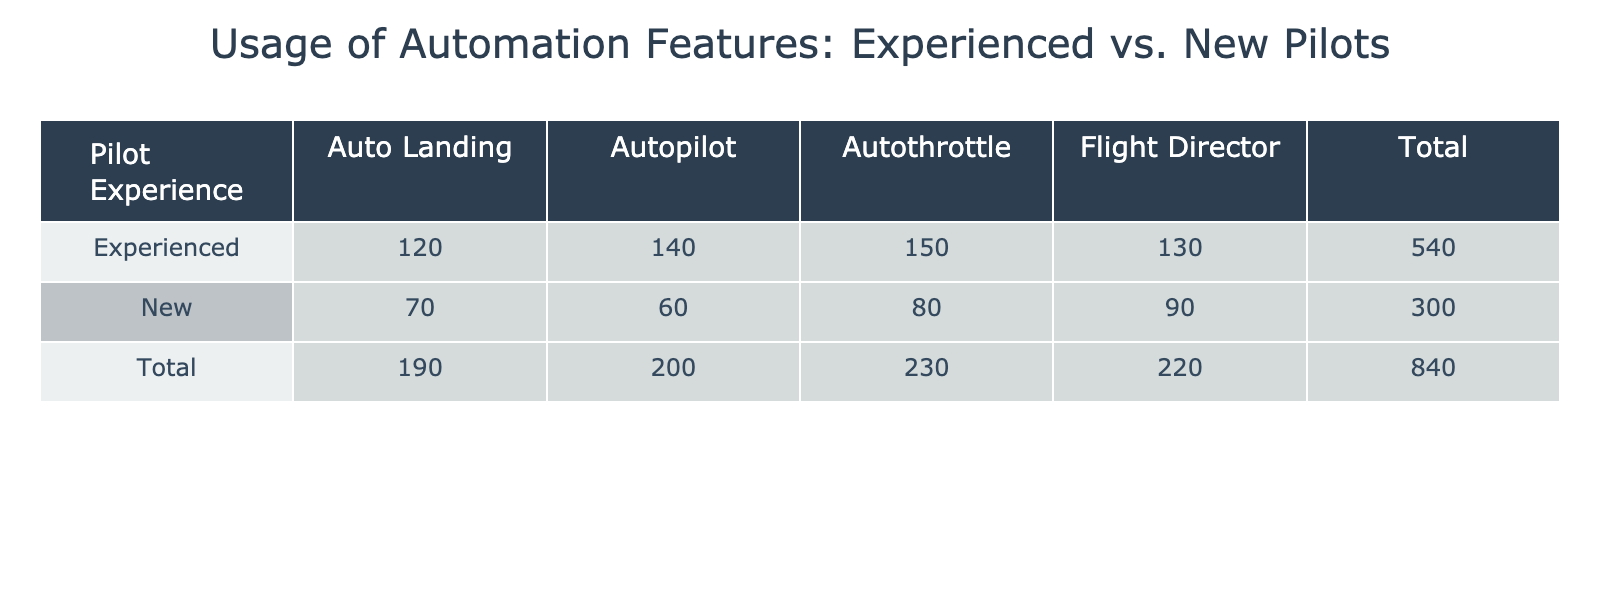What is the usage count for the Autopilot feature by Experienced pilots? Referring to the table, the usage count for the Autopilot feature under the Experienced category is directly given as 140.
Answer: 140 What is the total usage count for Automation Features by New pilots? Looking at the New pilots' row, the usage counts are 80 for Autothrottle, 90 for Flight Director, 70 for Auto Landing, and 60 for Autopilot. Adding these gives 80 + 90 + 70 + 60 = 300.
Answer: 300 Do Experienced pilots use Auto Landing more than New pilots? The usage count for Auto Landing by Experienced pilots is 120, while New pilots have a count of 70. Since 120 is greater than 70, the answer is yes.
Answer: Yes What is the difference in usage count for the Autothrottle feature between Experienced and New pilots? The usage count for Autothrottle is 150 for Experienced pilots and 80 for New pilots. The difference is calculated as 150 - 80 = 70.
Answer: 70 What is the average usage count of the Flight Director feature across both Experienced and New pilots? The usage count for Flight Director is 130 for Experienced pilots and 90 for New pilots. To find the average, add the two values (130 + 90 = 220) and divide by the number of groups (2). Thus, the average is 220 / 2 = 110.
Answer: 110 Which Automation Feature has the highest total usage count? To determine which feature has the highest total, we need to sum the counts for each feature across both Experienced and New pilots. Autothrottle (150 + 80 = 230), Flight Director (130 + 90 = 220), Auto Landing (120 + 70 = 190), and Autopilot (140 + 60 = 200). Autothrottle has the highest count of 230.
Answer: Autothrottle Is it true that Experienced pilots have a higher total usage count than New pilots for all features combined? The total for Experienced pilots is 150 + 130 + 120 + 140 = 540. The total for New pilots is 80 + 90 + 70 + 60 = 300. Since 540 is greater than 300, the statement is true.
Answer: True What is the total usage count for Autopilot across both levels of experience? The usage count for Autopilot is 140 for Experienced pilots and 60 for New pilots. Therefore, the total is 140 + 60 = 200.
Answer: 200 